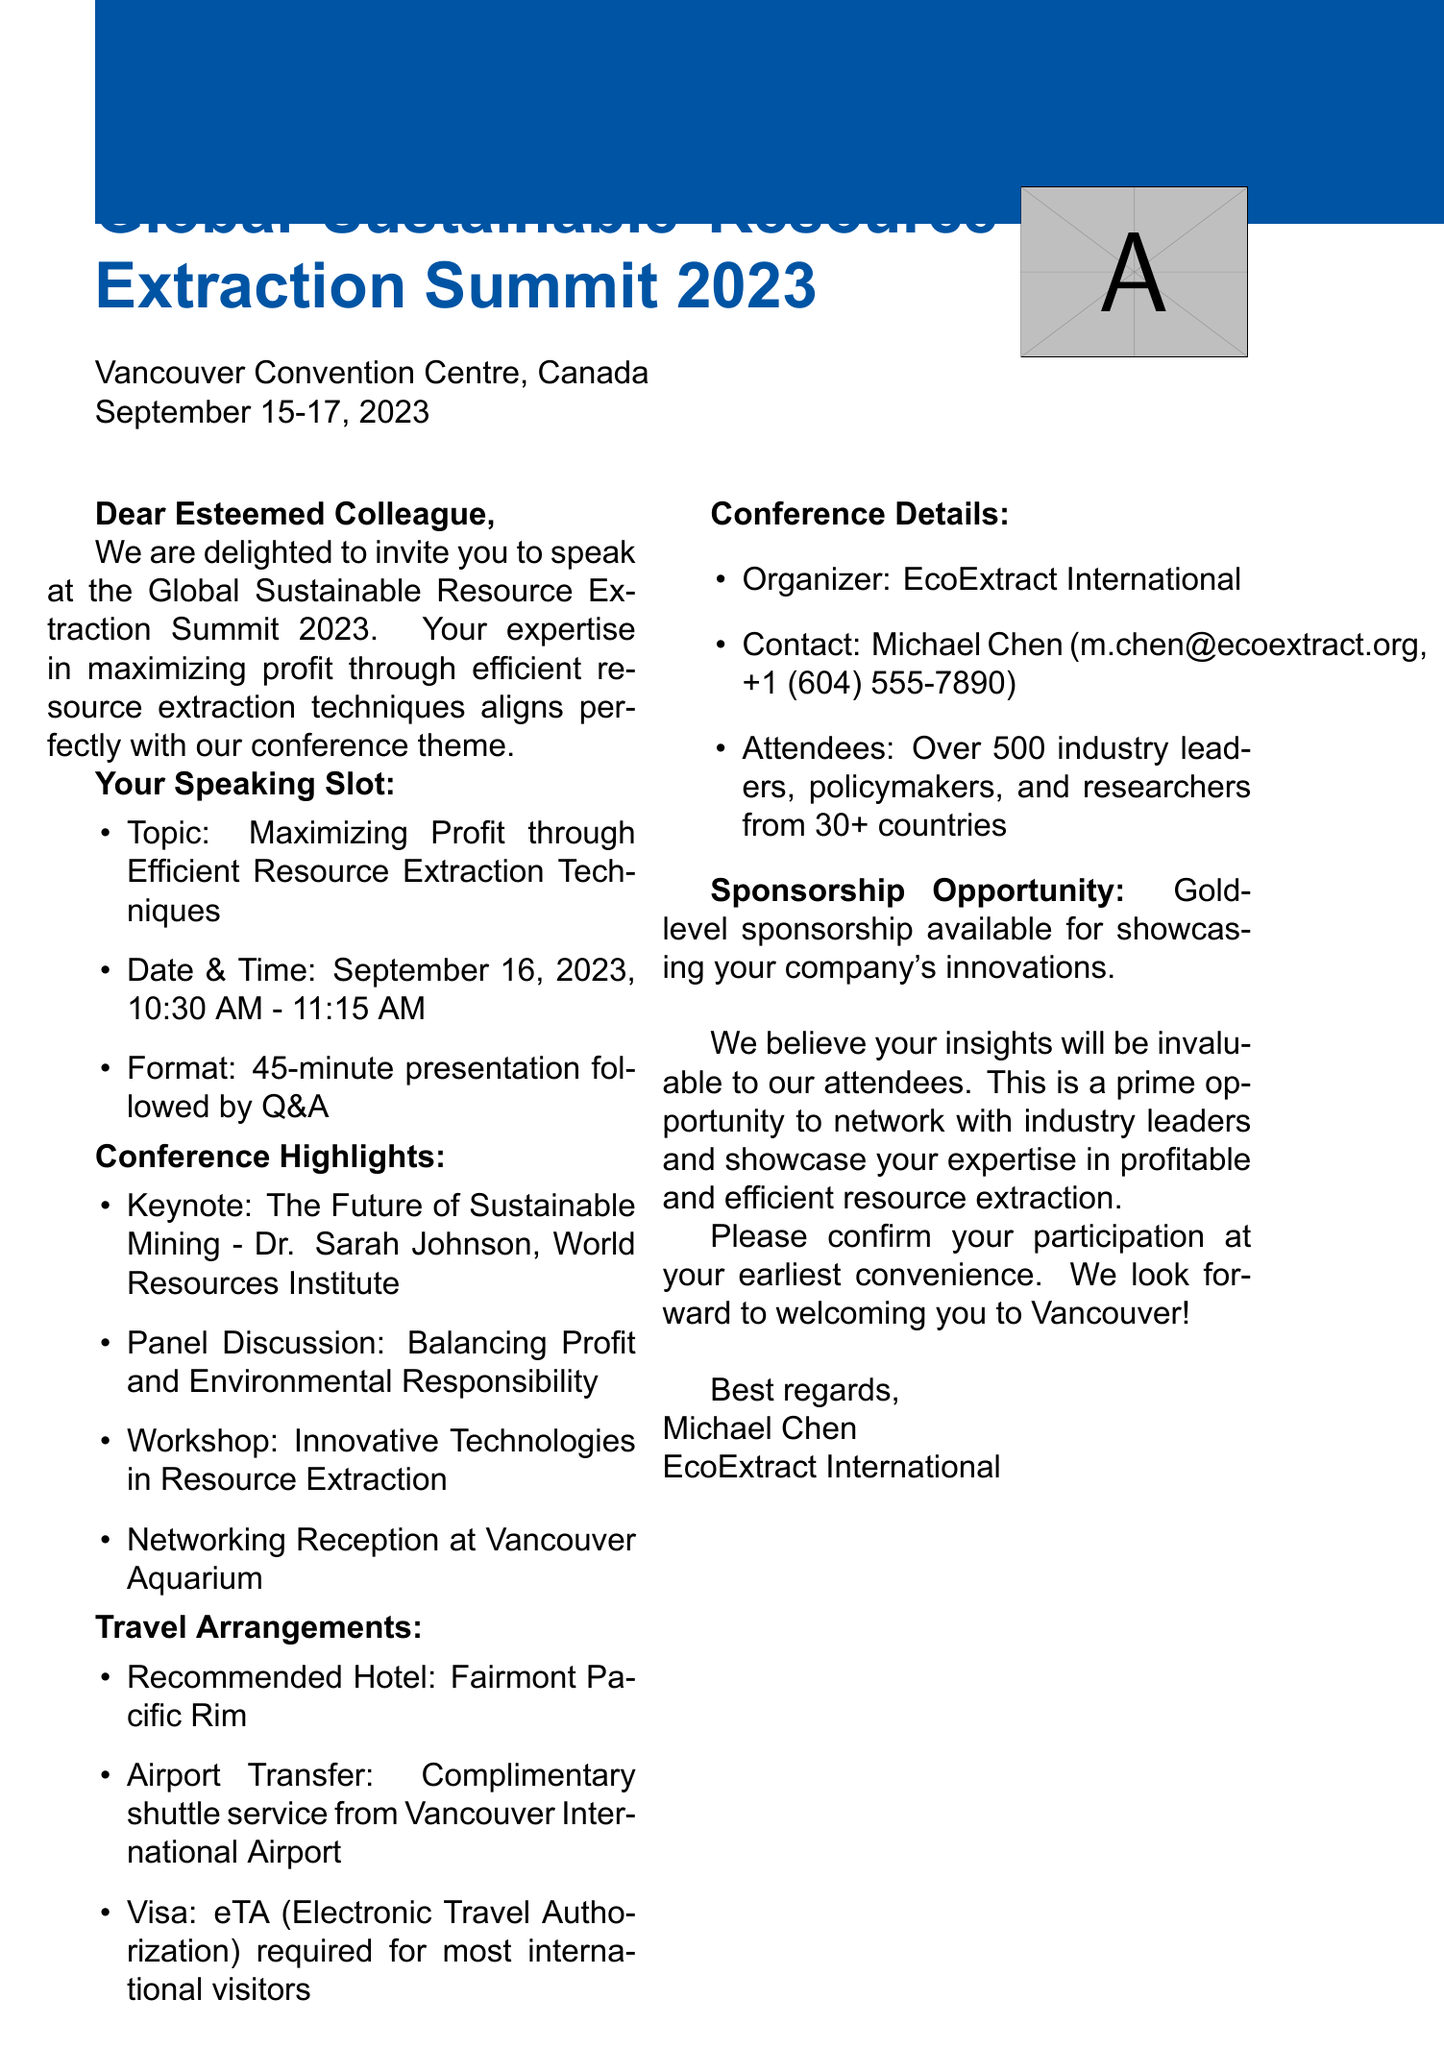What is the name of the conference? The document states the conference name explicitly at the beginning.
Answer: Global Sustainable Resource Extraction Summit 2023 Where is the conference located? The location of the conference is mentioned in the document.
Answer: Vancouver Convention Centre, Canada What is the date of the speaking slot? The specific date of the speaking slot is detailed under the invitation details section.
Answer: September 16, 2023 Who is the keynote speaker mentioned? The document highlights the keynote speaker in the agenda section.
Answer: Dr. Sarah Johnson What is required for most international visitors? The visa requirements are clearly stated in the travel arrangements section.
Answer: eTA (Electronic Travel Authorization) What is one of the agenda highlights? The document lists several highlights in the agenda section.
Answer: Balancing Profit and Environmental Responsibility How long is the presentation? The format of the speaking slot explains the duration of the presentation.
Answer: 45-minute presentation What is the contact email for the organizer? The contact email for the organizer is included in the conference details section.
Answer: m.chen@ecoextract.org What opportunity is available for showcasing innovations? The sponsorship opportunity is specified towards the end of the document.
Answer: Gold-level sponsorship 